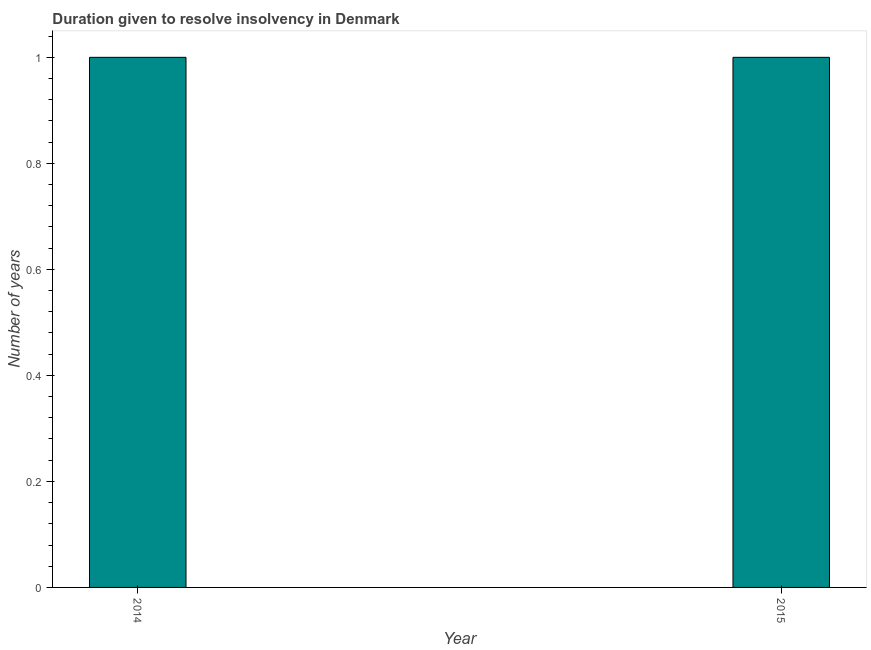Does the graph contain any zero values?
Ensure brevity in your answer.  No. Does the graph contain grids?
Provide a succinct answer. No. What is the title of the graph?
Give a very brief answer. Duration given to resolve insolvency in Denmark. What is the label or title of the Y-axis?
Give a very brief answer. Number of years. What is the number of years to resolve insolvency in 2014?
Offer a very short reply. 1. Across all years, what is the maximum number of years to resolve insolvency?
Your answer should be compact. 1. Across all years, what is the minimum number of years to resolve insolvency?
Offer a very short reply. 1. In which year was the number of years to resolve insolvency maximum?
Provide a succinct answer. 2014. What is the sum of the number of years to resolve insolvency?
Provide a succinct answer. 2. Do a majority of the years between 2015 and 2014 (inclusive) have number of years to resolve insolvency greater than 0.68 ?
Ensure brevity in your answer.  No. In how many years, is the number of years to resolve insolvency greater than the average number of years to resolve insolvency taken over all years?
Your response must be concise. 0. How many bars are there?
Give a very brief answer. 2. Are all the bars in the graph horizontal?
Make the answer very short. No. How many years are there in the graph?
Your response must be concise. 2. What is the difference between the Number of years in 2014 and 2015?
Your answer should be compact. 0. 